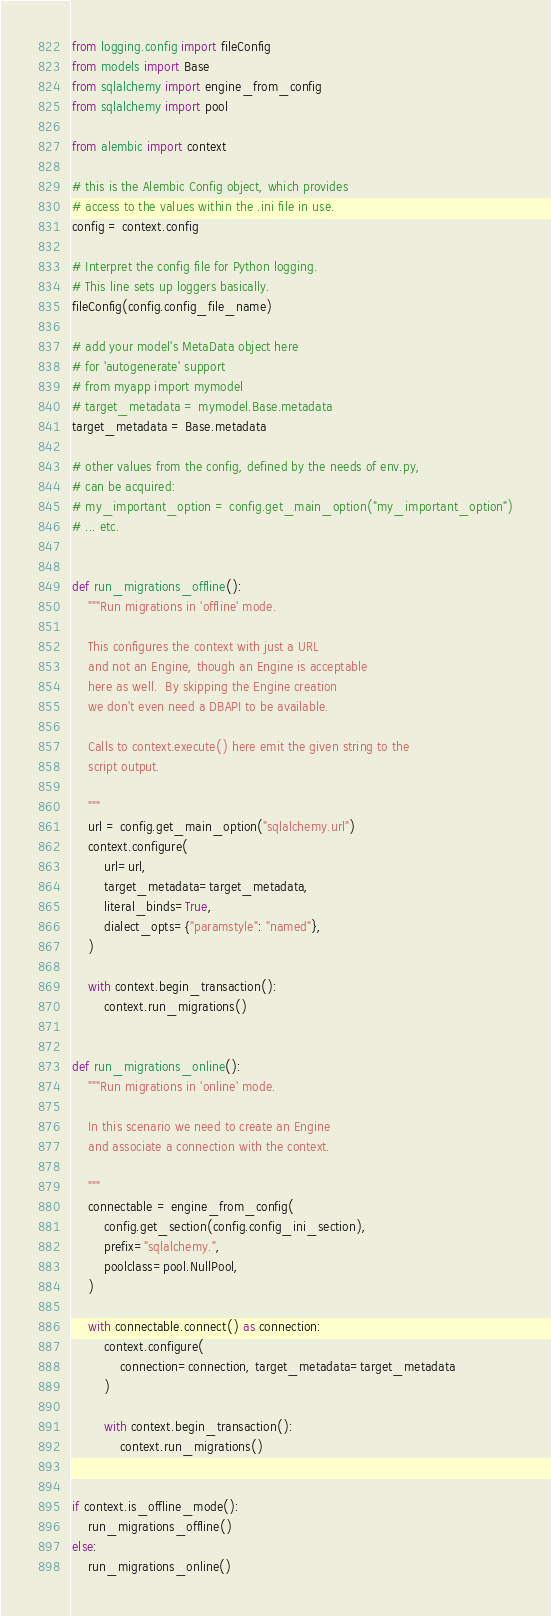<code> <loc_0><loc_0><loc_500><loc_500><_Python_>from logging.config import fileConfig
from models import Base
from sqlalchemy import engine_from_config
from sqlalchemy import pool

from alembic import context

# this is the Alembic Config object, which provides
# access to the values within the .ini file in use.
config = context.config

# Interpret the config file for Python logging.
# This line sets up loggers basically.
fileConfig(config.config_file_name)

# add your model's MetaData object here
# for 'autogenerate' support
# from myapp import mymodel
# target_metadata = mymodel.Base.metadata
target_metadata = Base.metadata

# other values from the config, defined by the needs of env.py,
# can be acquired:
# my_important_option = config.get_main_option("my_important_option")
# ... etc.


def run_migrations_offline():
    """Run migrations in 'offline' mode.

    This configures the context with just a URL
    and not an Engine, though an Engine is acceptable
    here as well.  By skipping the Engine creation
    we don't even need a DBAPI to be available.

    Calls to context.execute() here emit the given string to the
    script output.

    """
    url = config.get_main_option("sqlalchemy.url")
    context.configure(
        url=url,
        target_metadata=target_metadata,
        literal_binds=True,
        dialect_opts={"paramstyle": "named"},
    )

    with context.begin_transaction():
        context.run_migrations()


def run_migrations_online():
    """Run migrations in 'online' mode.

    In this scenario we need to create an Engine
    and associate a connection with the context.

    """
    connectable = engine_from_config(
        config.get_section(config.config_ini_section),
        prefix="sqlalchemy.",
        poolclass=pool.NullPool,
    )

    with connectable.connect() as connection:
        context.configure(
            connection=connection, target_metadata=target_metadata
        )

        with context.begin_transaction():
            context.run_migrations()


if context.is_offline_mode():
    run_migrations_offline()
else:
    run_migrations_online()
</code> 